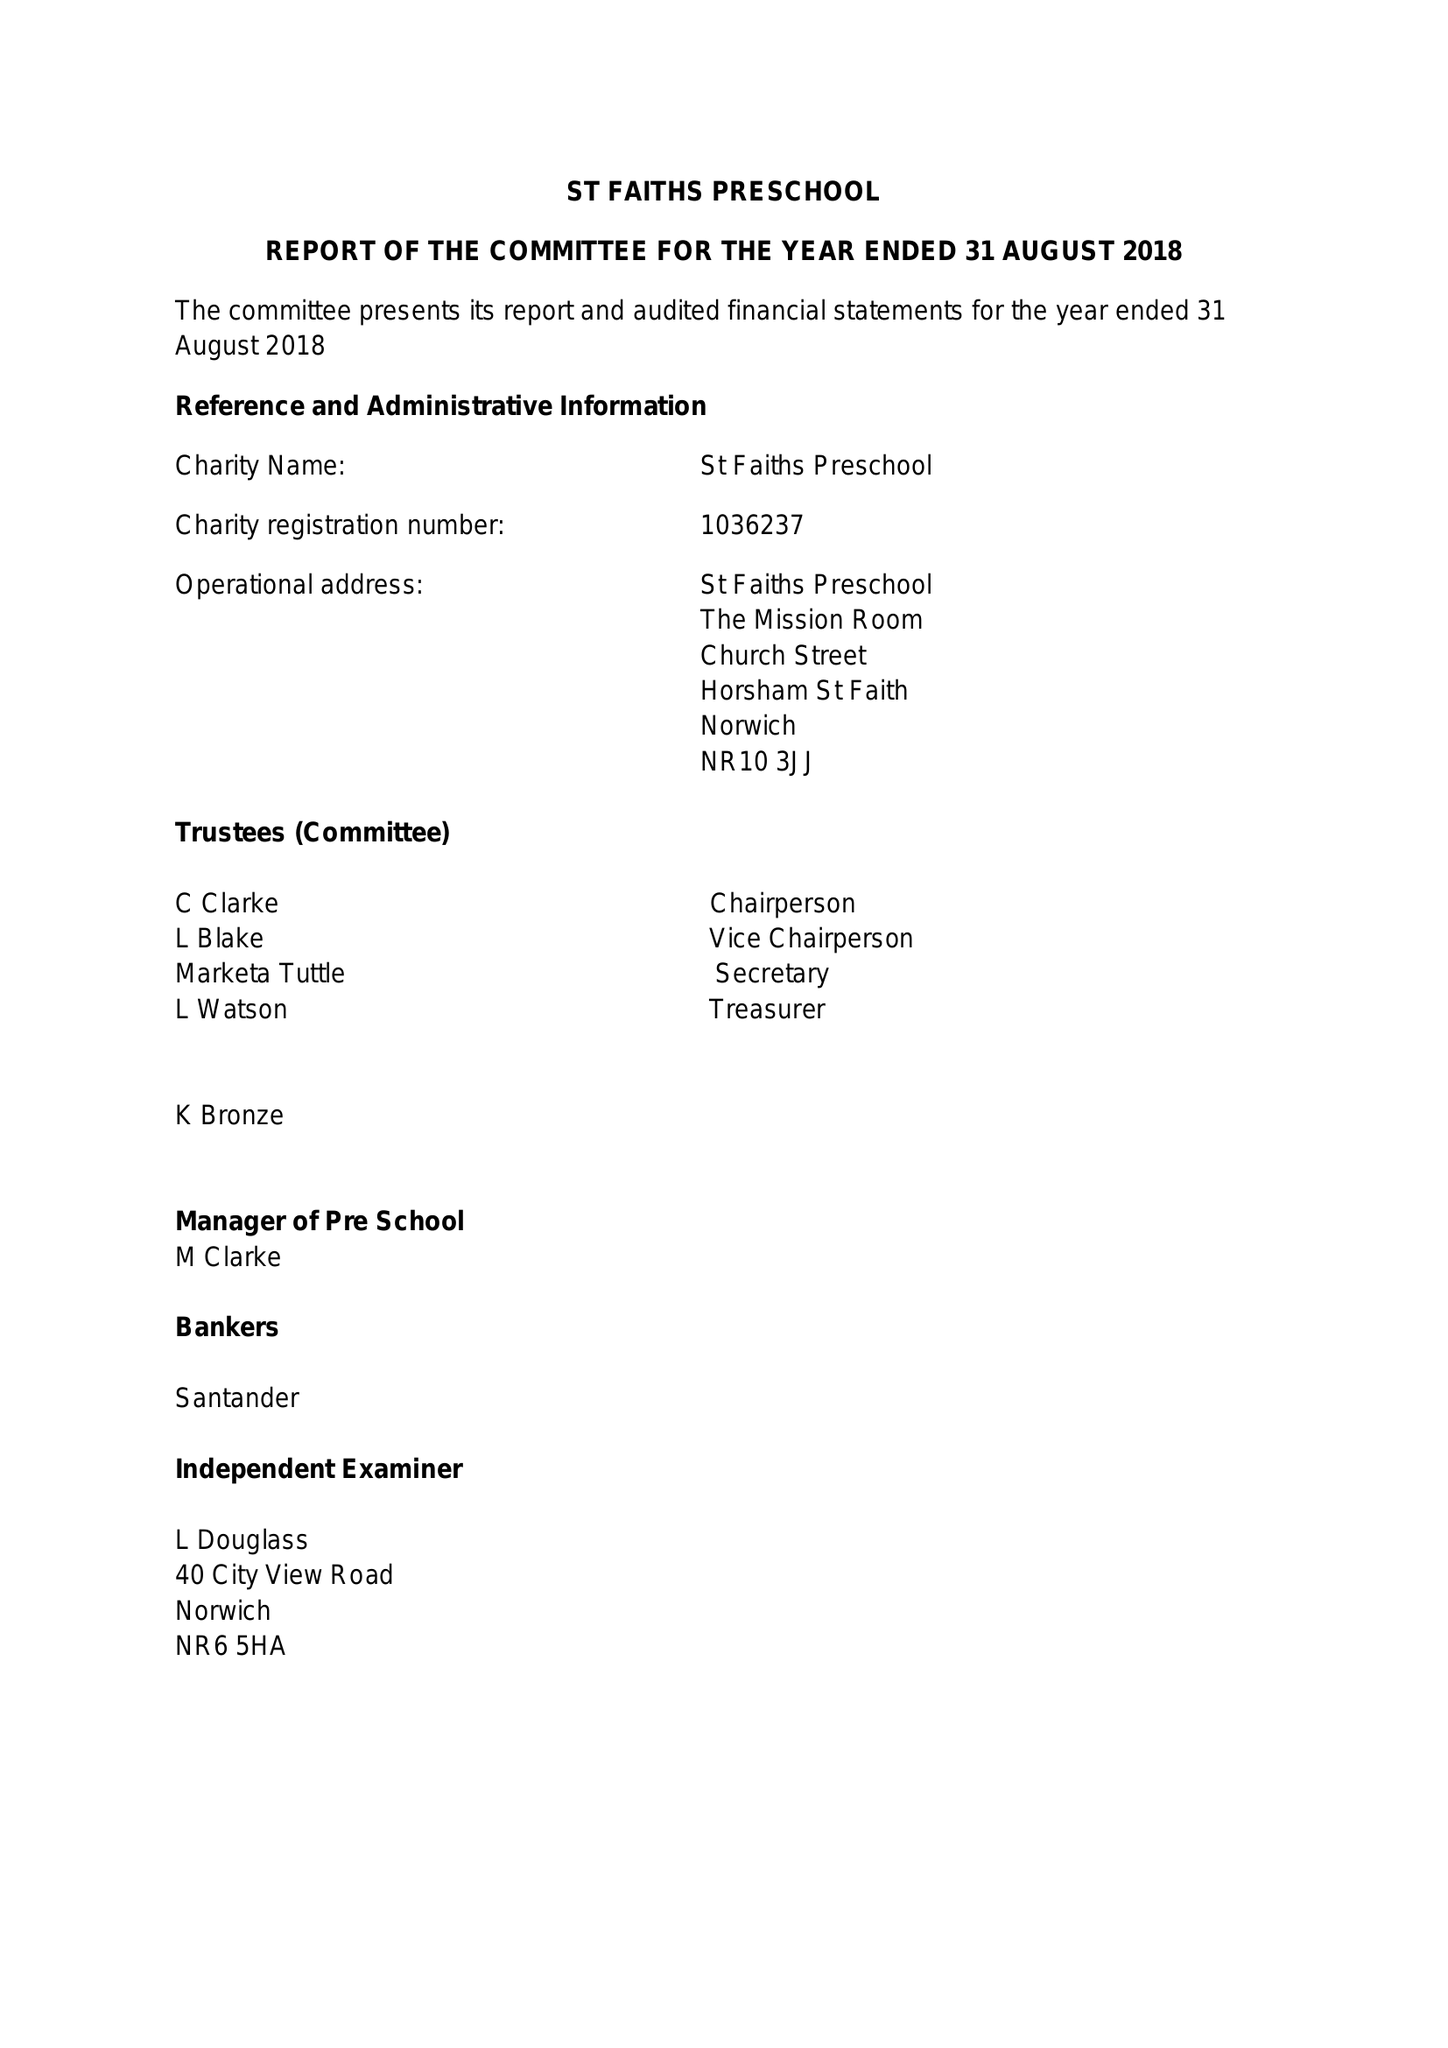What is the value for the report_date?
Answer the question using a single word or phrase. 2018-08-31 